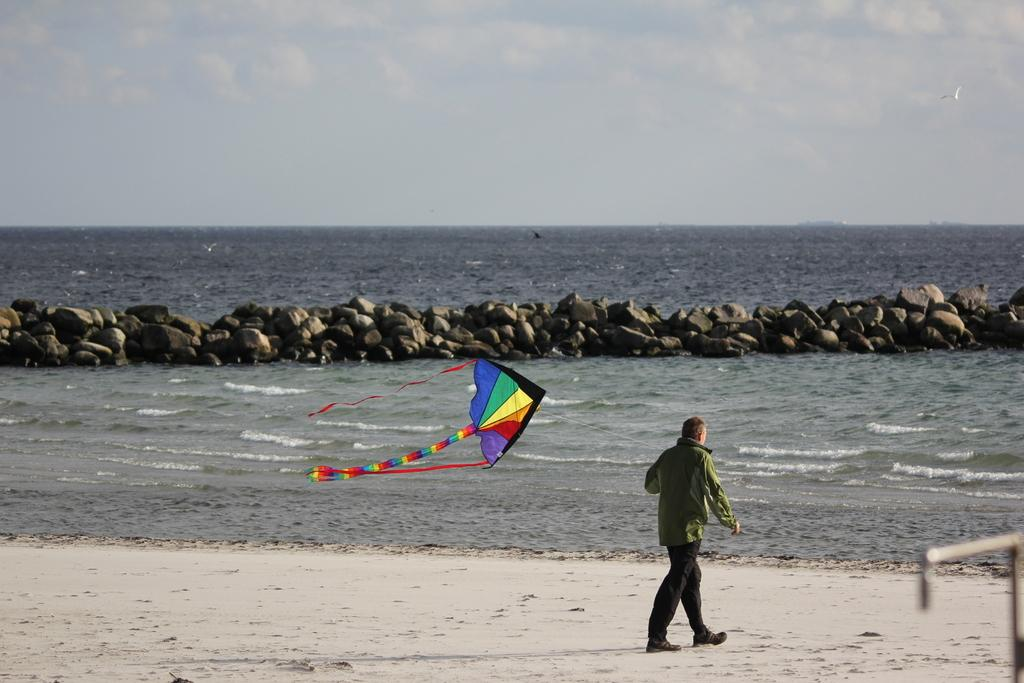What is located in the foreground of the image? There is a person and a kite in the foreground of the image. What can be seen in the background of the image? There are stones, water, and the sky visible in the background of the image. Where is the zoo located in the image? There is no zoo present in the image. What type of quiver is being used by the person in the image? There is no quiver visible in the image. 